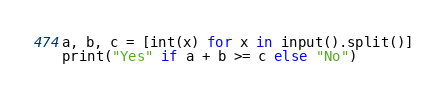Convert code to text. <code><loc_0><loc_0><loc_500><loc_500><_Python_>a, b, c = [int(x) for x in input().split()]
print("Yes" if a + b >= c else "No")</code> 